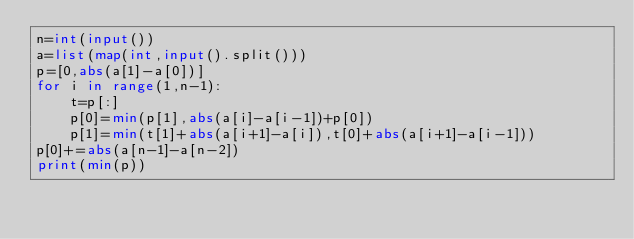Convert code to text. <code><loc_0><loc_0><loc_500><loc_500><_Python_>n=int(input())
a=list(map(int,input().split()))
p=[0,abs(a[1]-a[0])]
for i in range(1,n-1):
    t=p[:]
    p[0]=min(p[1],abs(a[i]-a[i-1])+p[0])
    p[1]=min(t[1]+abs(a[i+1]-a[i]),t[0]+abs(a[i+1]-a[i-1]))
p[0]+=abs(a[n-1]-a[n-2])
print(min(p))</code> 